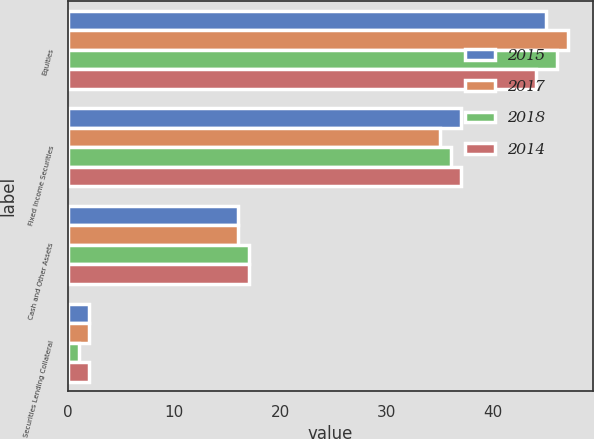<chart> <loc_0><loc_0><loc_500><loc_500><stacked_bar_chart><ecel><fcel>Equities<fcel>Fixed Income Securities<fcel>Cash and Other Assets<fcel>Securities Lending Collateral<nl><fcel>2015<fcel>45<fcel>37<fcel>16<fcel>2<nl><fcel>2017<fcel>47<fcel>35<fcel>16<fcel>2<nl><fcel>2018<fcel>46<fcel>36<fcel>17<fcel>1<nl><fcel>2014<fcel>44<fcel>37<fcel>17<fcel>2<nl></chart> 